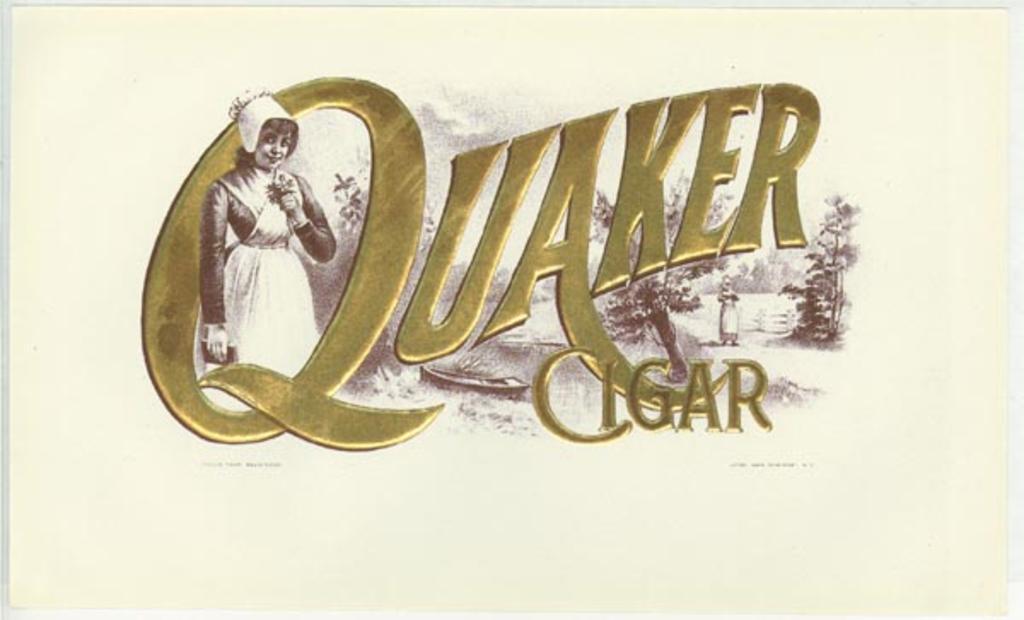Please provide a concise description of this image. In the image we can see the poster. In it we can see picture of woman standing, wearing clothes and she is smiling. Here we can see the text. 